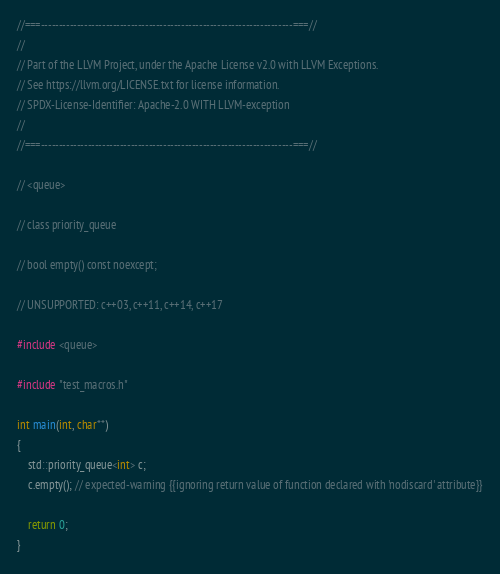<code> <loc_0><loc_0><loc_500><loc_500><_C++_>//===----------------------------------------------------------------------===//
//
// Part of the LLVM Project, under the Apache License v2.0 with LLVM Exceptions.
// See https://llvm.org/LICENSE.txt for license information.
// SPDX-License-Identifier: Apache-2.0 WITH LLVM-exception
//
//===----------------------------------------------------------------------===//

// <queue>

// class priority_queue

// bool empty() const noexcept;

// UNSUPPORTED: c++03, c++11, c++14, c++17

#include <queue>

#include "test_macros.h"

int main(int, char**)
{
    std::priority_queue<int> c;
    c.empty(); // expected-warning {{ignoring return value of function declared with 'nodiscard' attribute}}

    return 0;
}
</code> 